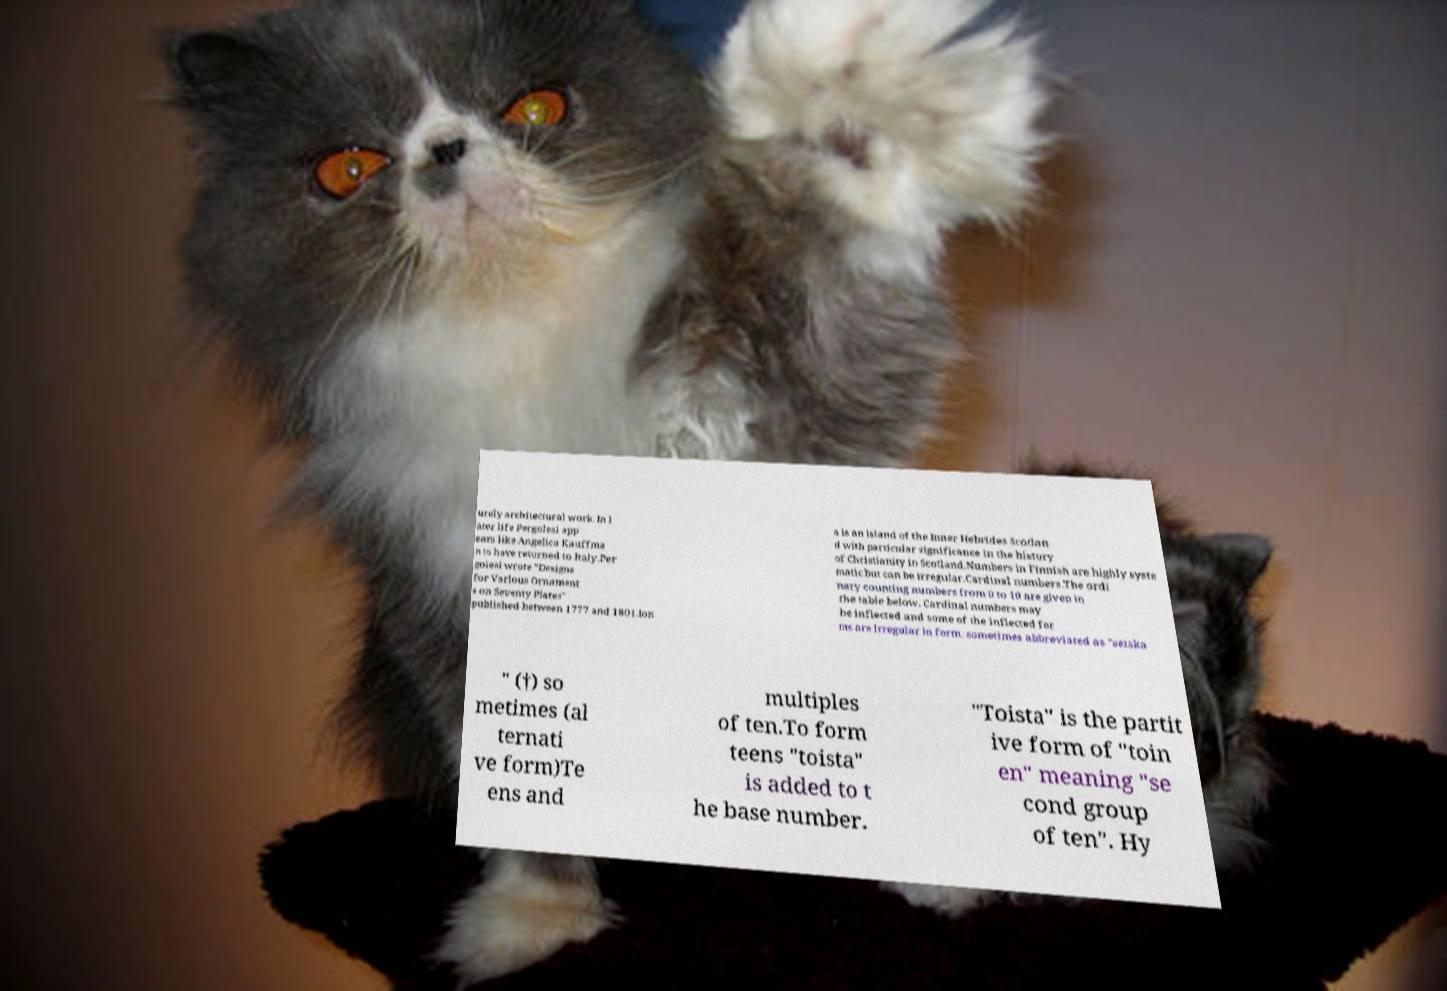Please read and relay the text visible in this image. What does it say? urely architectural work. In l ater life Pergolesi app ears like Angelica Kauffma n to have returned to Italy.Per golesi wrote "Designs for Various Ornament s on Seventy Plates" published between 1777 and 1801.Ion a is an island of the Inner Hebrides Scotlan d with particular significance in the history of Christianity in Scotland.Numbers in Finnish are highly syste matic but can be irregular.Cardinal numbers.The ordi nary counting numbers from 0 to 10 are given in the table below. Cardinal numbers may be inflected and some of the inflected for ms are irregular in form. sometimes abbreviated as "seiska " (†) so metimes (al ternati ve form)Te ens and multiples of ten.To form teens "toista" is added to t he base number. "Toista" is the partit ive form of "toin en" meaning "se cond group of ten". Hy 